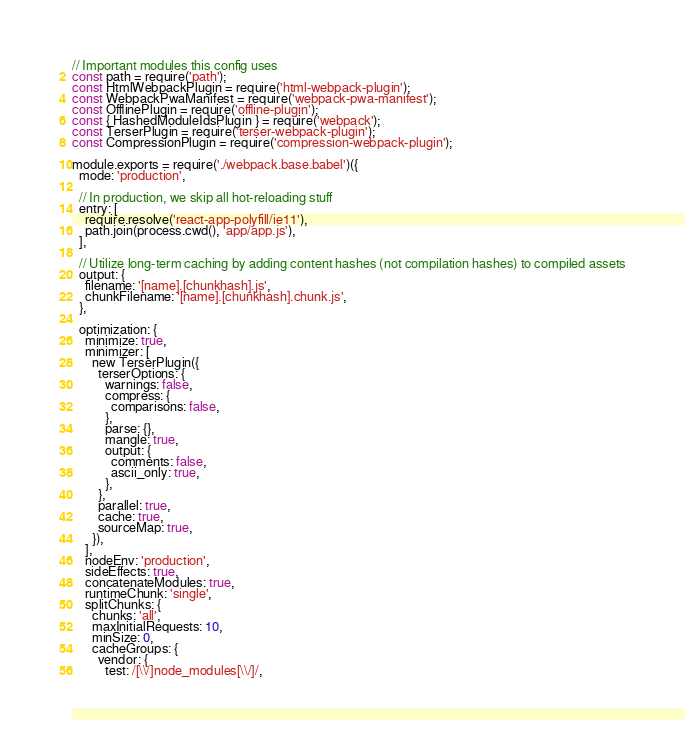Convert code to text. <code><loc_0><loc_0><loc_500><loc_500><_JavaScript_>// Important modules this config uses
const path = require('path');
const HtmlWebpackPlugin = require('html-webpack-plugin');
const WebpackPwaManifest = require('webpack-pwa-manifest');
const OfflinePlugin = require('offline-plugin');
const { HashedModuleIdsPlugin } = require('webpack');
const TerserPlugin = require('terser-webpack-plugin');
const CompressionPlugin = require('compression-webpack-plugin');

module.exports = require('./webpack.base.babel')({
  mode: 'production',

  // In production, we skip all hot-reloading stuff
  entry: [
    require.resolve('react-app-polyfill/ie11'),
    path.join(process.cwd(), 'app/app.js'),
  ],

  // Utilize long-term caching by adding content hashes (not compilation hashes) to compiled assets
  output: {
    filename: '[name].[chunkhash].js',
    chunkFilename: '[name].[chunkhash].chunk.js',
  },

  optimization: {
    minimize: true,
    minimizer: [
      new TerserPlugin({
        terserOptions: {
          warnings: false,
          compress: {
            comparisons: false,
          },
          parse: {},
          mangle: true,
          output: {
            comments: false,
            ascii_only: true,
          },
        },
        parallel: true,
        cache: true,
        sourceMap: true,
      }),
    ],
    nodeEnv: 'production',
    sideEffects: true,
    concatenateModules: true,
    runtimeChunk: 'single',
    splitChunks: {
      chunks: 'all',
      maxInitialRequests: 10,
      minSize: 0,
      cacheGroups: {
        vendor: {
          test: /[\\/]node_modules[\\/]/,</code> 